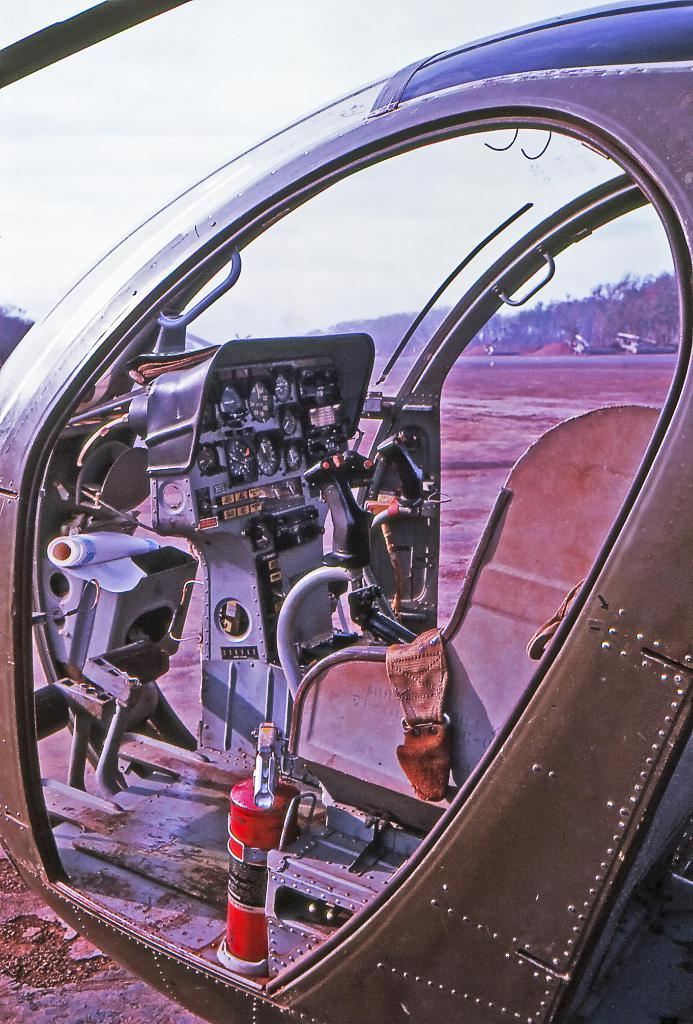What type of image is being shown? The image is an edited picture. What can be seen in the sky of the image? The sky is cloudy in the image. What is located in the center of the image? There is soil in the center of the image. What type of vegetation is visible in the background of the image? There are trees in the background of the image. What mode of transportation is present in the image? There is a helicopter in the image. How many zebras can be seen grazing on the mountain in the image? There are no zebras or mountains present in the image; it features a helicopter, soil, trees, and a cloudy sky. 